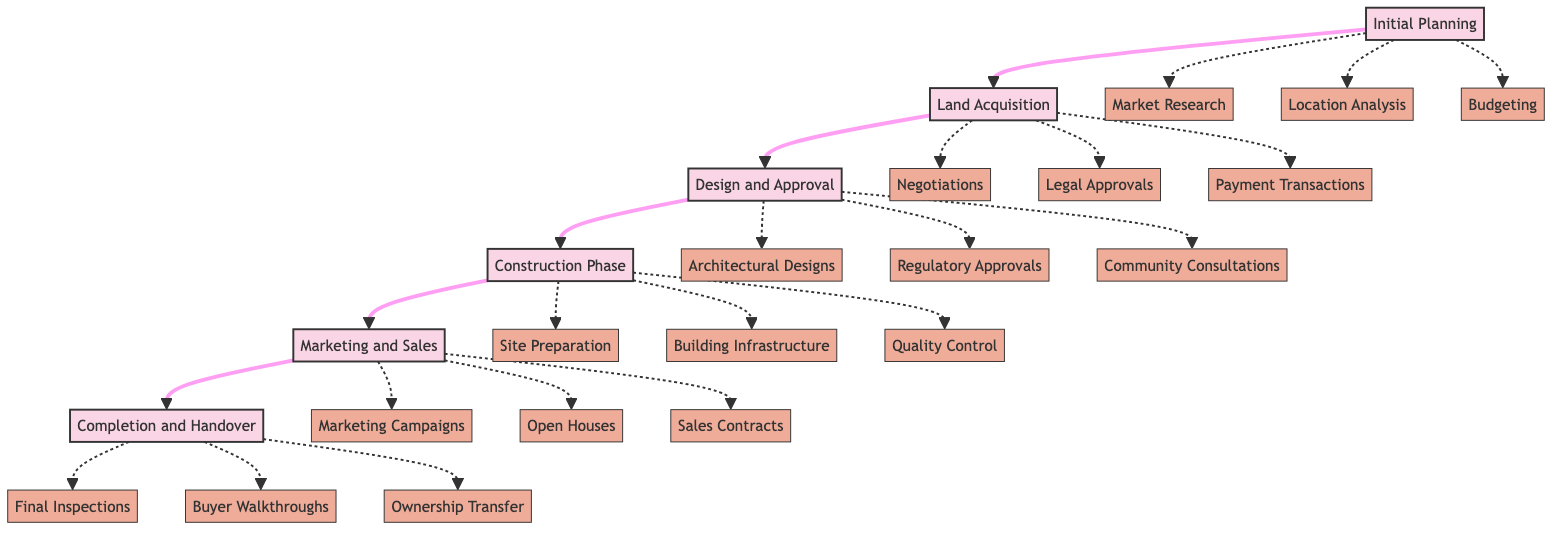What is the first phase in the timeline? The first phase indicated in the diagram is "Initial Planning." It is the starting point before any other phases begin.
Answer: Initial Planning How many phases are in the Luxury Housing Project Timeline? The diagram shows five distinct phases: Initial Planning, Land Acquisition, Design and Approval, Construction Phase, Marketing and Sales, and Completion and Handover. Counting them gives a total of six phases.
Answer: Six What phase comes after "Design and Approval"? The diagram states that "Construction Phase" follows "Design and Approval." This is the next step in the project timeline.
Answer: Construction Phase What key entity is associated with "Marketing and Sales"? The phase "Marketing and Sales" includes several key entities, one of which is "Marketing Campaigns." It is listed directly under this phase.
Answer: Marketing Campaigns Which phase includes "Final Inspections"? "Final Inspections" is a key entity under the "Completion and Handover" phase, indicating that this is when the final checks are made before handing over the property.
Answer: Completion and Handover What key entity is not part of the Construction Phase? The key entities listed under "Construction Phase" include Site Preparation, Building Infrastructure, and Quality Control. Therefore, "Negotiations" is not part of this phase.
Answer: Negotiations Which phase connects directly to "Land Acquisition"? "Initial Planning" directly connects to "Land Acquisition," showing that once planning is complete, the focus moves to acquiring land.
Answer: Initial Planning How do "Community Consultations" play a role in the process? "Community Consultations" are part of the "Design and Approval" phase, indicating that engaging with the community is essential before moving on to the construction process.
Answer: Design and Approval What is the final step after "Marketing and Sales"? According to the diagram, "Completion and Handover" is the final step that occurs after successful marketing and sales of the properties.
Answer: Completion and Handover 